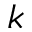Convert formula to latex. <formula><loc_0><loc_0><loc_500><loc_500>k</formula> 